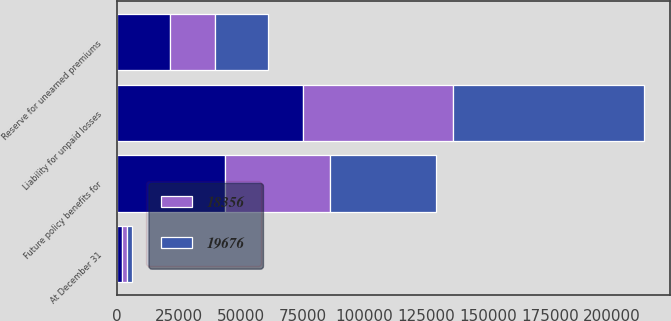<chart> <loc_0><loc_0><loc_500><loc_500><stacked_bar_chart><ecel><fcel>At December 31<fcel>Liability for unpaid losses<fcel>Future policy benefits for<fcel>Reserve for unearned premiums<nl><fcel>nan<fcel>2015<fcel>74942<fcel>43585<fcel>21318<nl><fcel>18356<fcel>2015<fcel>60603<fcel>42506<fcel>18380<nl><fcel>19676<fcel>2014<fcel>77260<fcel>42749<fcel>21324<nl></chart> 